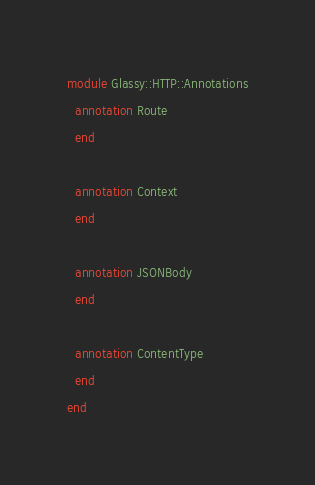Convert code to text. <code><loc_0><loc_0><loc_500><loc_500><_Crystal_>module Glassy::HTTP::Annotations
  annotation Route
  end

  annotation Context
  end

  annotation JSONBody
  end

  annotation ContentType
  end
end
</code> 